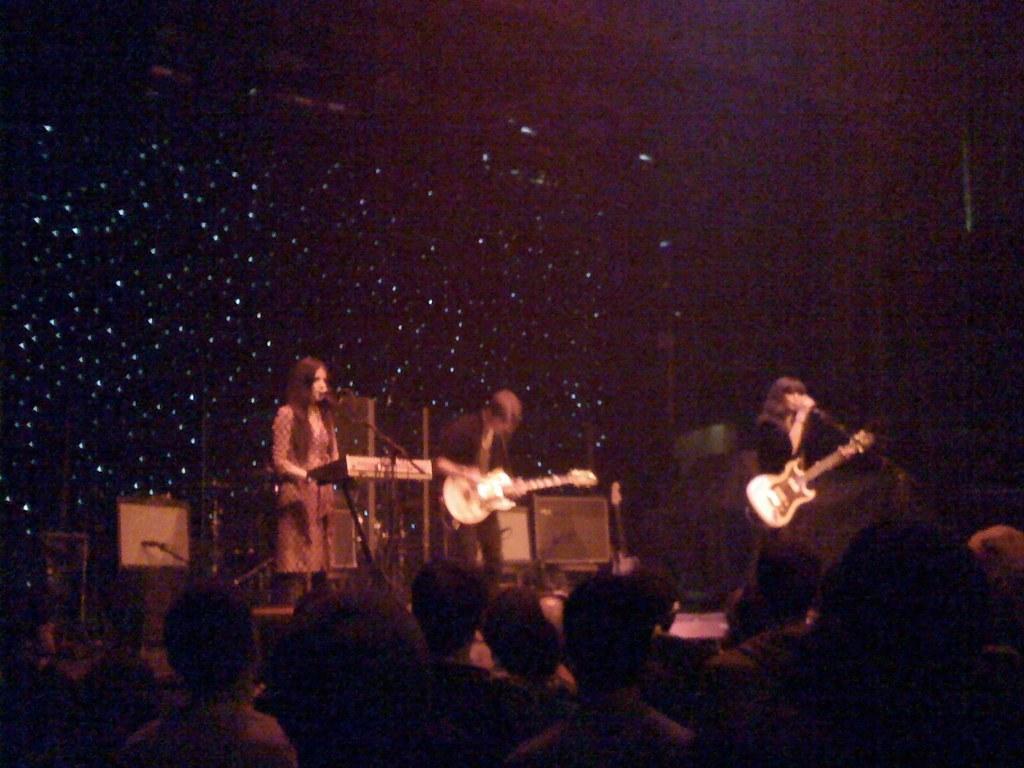Describe this image in one or two sentences. A girl is playing keyboard and singing. In front of her there is a mic. Two persons are holding guitar playing. In the front there are some persons. In the background it is looking black. 